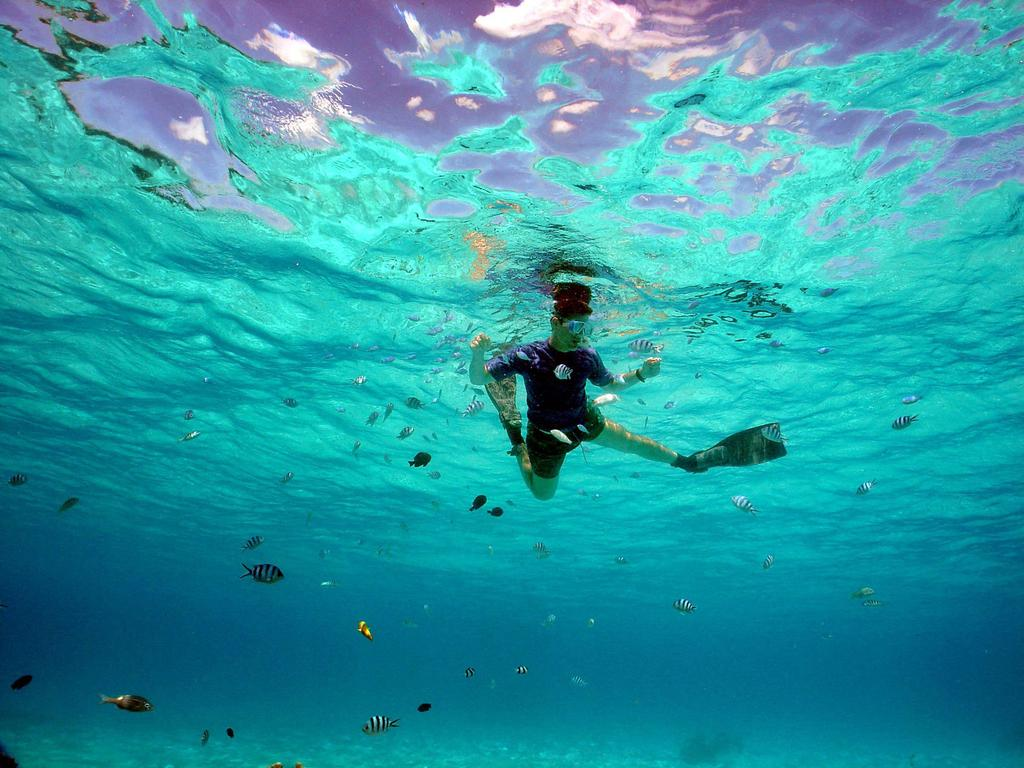What type of animals can be seen in the image? There are fishes in the image. Can you describe the person in the image? There is a person under the water in the image. What type of screw can be seen holding the cup in the image? There is no screw or cup present in the image; it features fishes and a person underwater. How many cards are visible in the image? There are no cards present in the image. 